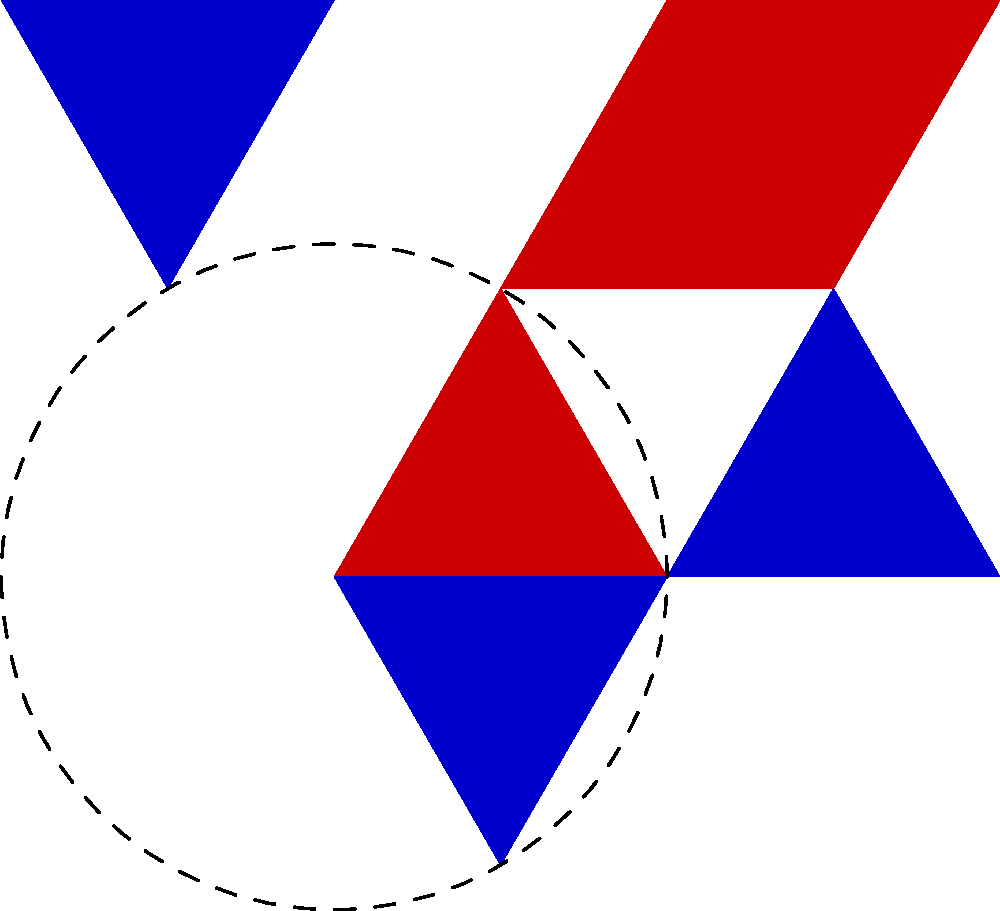You are designing a symmetric pattern for racing gloves using equilateral triangles. The base design consists of a red triangle at the origin, followed by alternating blue and red triangles in a circular arrangement. If the side length of each triangle is 2 units, and the pattern completes one full rotation, how many triangles are needed to form the entire symmetric design? Let's approach this step-by-step:

1) First, we need to understand the geometry of an equilateral triangle. In an equilateral triangle, all angles are 60°.

2) The pattern shown in the diagram completes a full 360° rotation around the center.

3) Each triangle in the pattern is rotated 60° relative to the previous one. This is because the triangles are placed edge-to-edge, and the angle at each vertex of an equilateral triangle is 60°.

4) To calculate the number of triangles needed, we divide the full rotation angle by the rotation angle between each triangle:

   $$\text{Number of triangles} = \frac{\text{Full rotation}}{\text{Rotation between triangles}} = \frac{360°}{60°} = 6$$

5) We can verify this by counting the triangles in the diagram: there are indeed 6 triangles (3 red and 3 blue) forming a complete circular pattern.

Therefore, 6 triangles are needed to form the entire symmetric design.
Answer: 6 triangles 